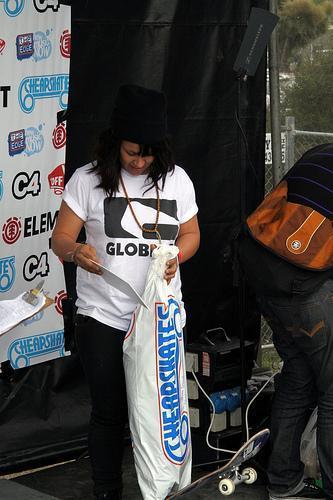How many skateboards?
Give a very brief answer. 1. 